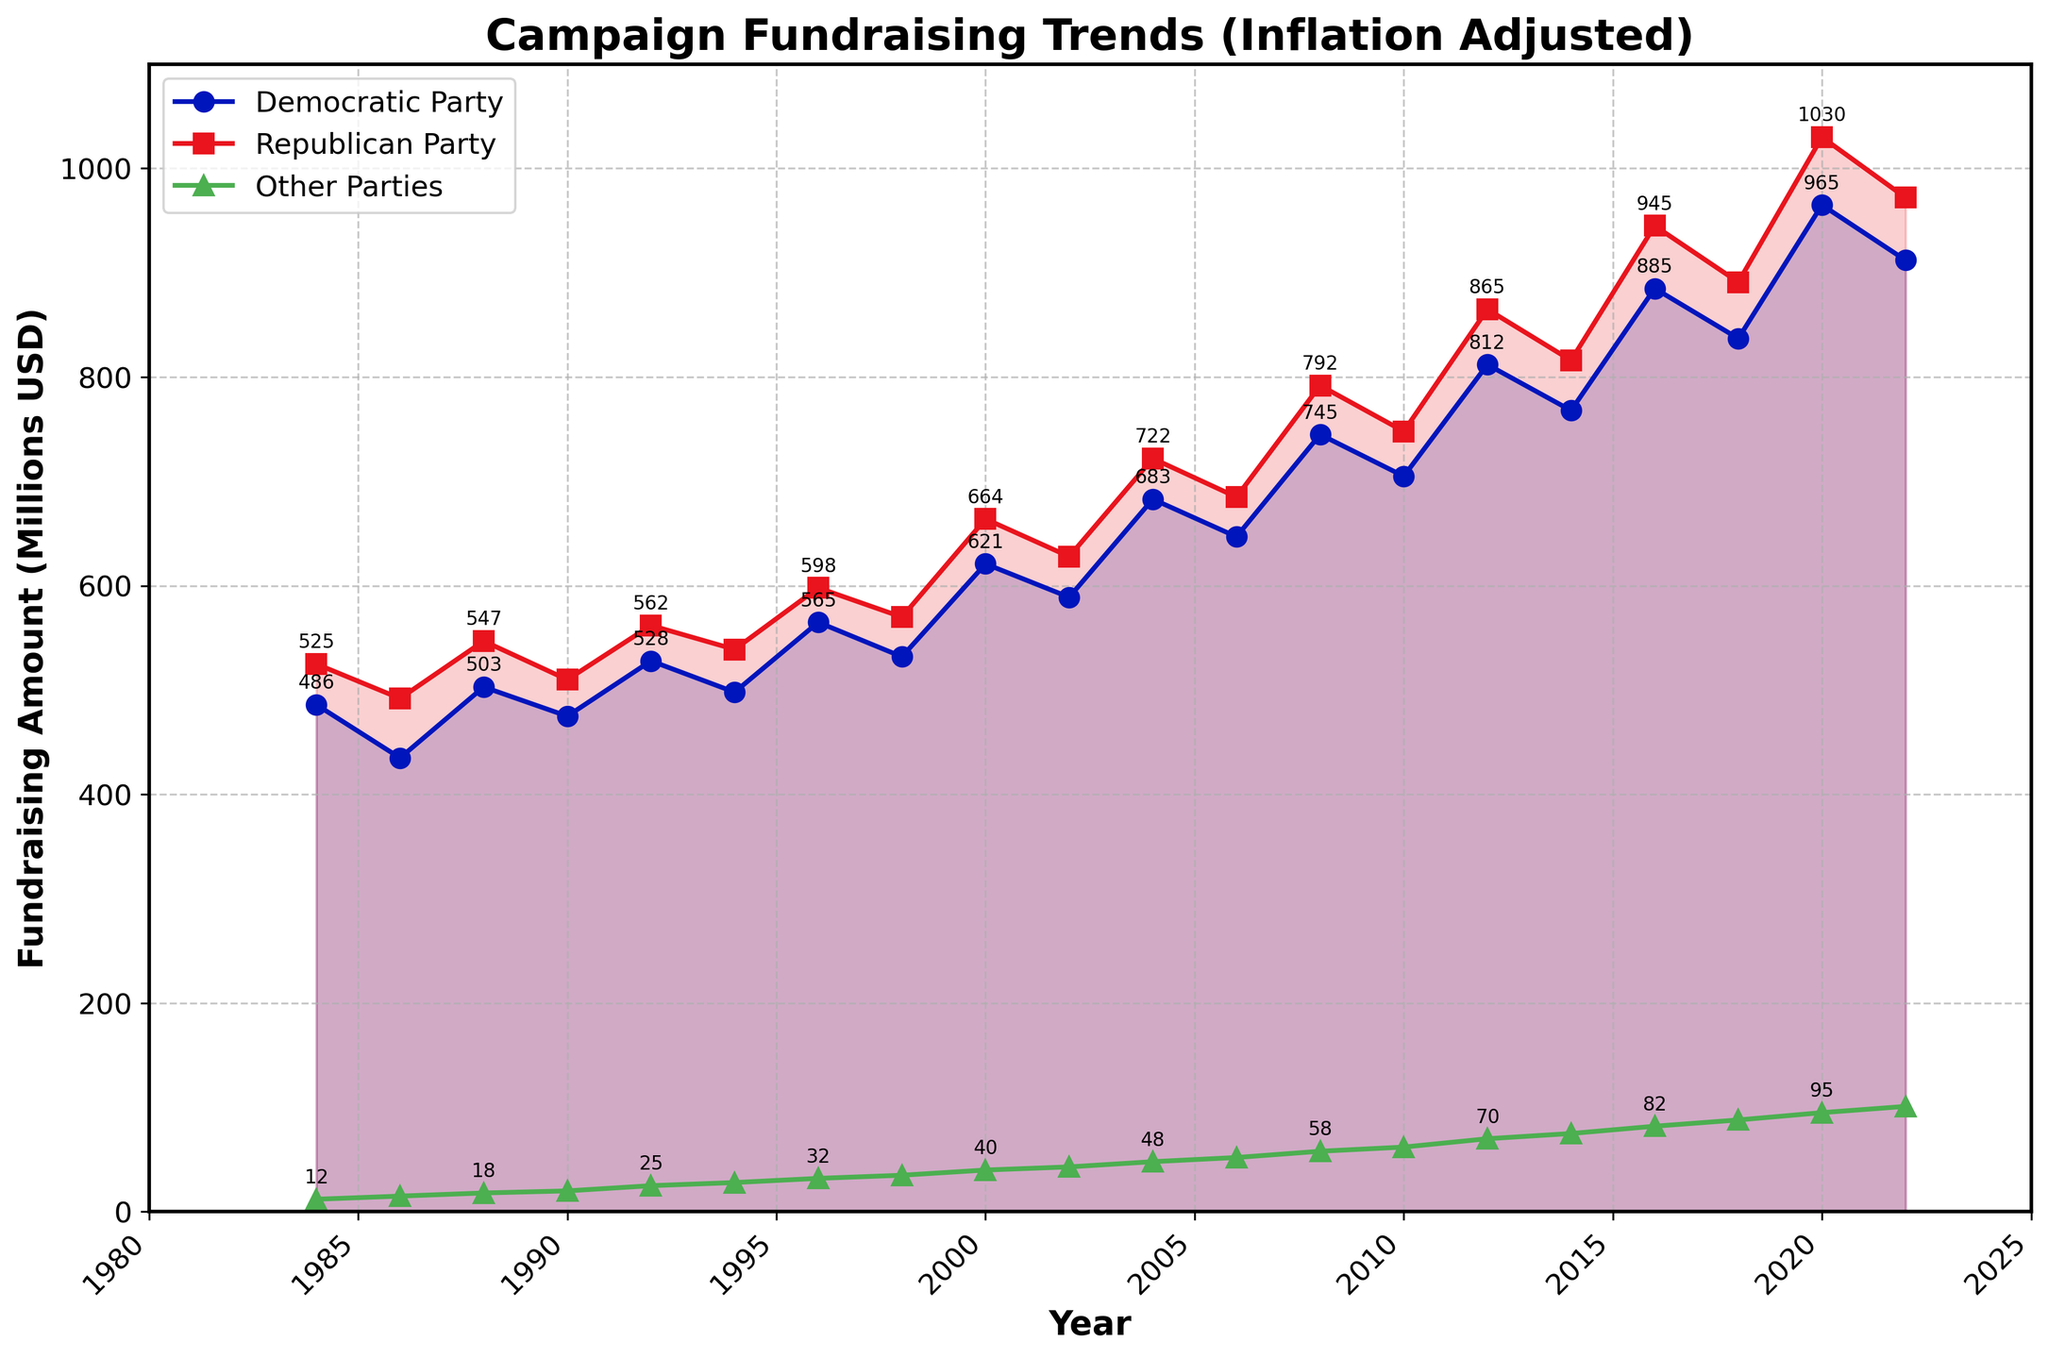What’s the total fundraising amount for Democratic and Republican parties in the year 2008? In 2008, the Democratic Party raised $745 million, and the Republican Party raised $792 million. Adding these amounts gives $745 + $792 = $1,537 million.
Answer: $1,537 million Which party had the highest fundraising in 2016? Comparing the amounts raised in 2016: The Democratic Party raised $885 million, the Republican Party raised $945 million, and Other Parties raised $82 million. The Republican Party had the highest fundraising.
Answer: Republican Party Between which years did the Democratic Party see the largest increase in fundraising? To determine the largest increase, compare the changes year-over-year for the Democratic Party. The biggest jump was from 2014 ($768 million) to 2016 ($885 million), an increase of $117 million.
Answer: 2014-2016 What is the average fundraising amount for Other Parties over the last 10 election cycles? Sum the fundraising amounts for Other Parties for each election year and divide by 10: (12+15+18+20+25+28+32+35+40+43+48+52+58+62+70+75+82+88+95+101) million. The average fundraising is (1237/20) = 61.85 million.
Answer: 61.85 million What trend is noticeable for the Republican Party fundraising from 2000 to 2020? Observing the year-over-year values for the Republican Party from 2000 ($664 million) to 2020 ($1030 million) we see an overall increasing trend, with each cycle generally raising a higher amount than the previous one.
Answer: Increasing trend In which years did the Democratic Party raise more than the Republican Party? Checking the plot, the Democratic Party raised more in the years: 1986, 1990, 2002, and 2006.
Answer: 1986, 1990, 2002, 2006 How much more did the Republican Party raise compared to the Democratic Party in 2020? In 2020, the Republican Party raised $1030 million, while the Democratic Party raised $965 million. The difference is $1030 - $965 = $65 million.
Answer: $65 million What color represents the fundraising trend of Other Parties in the chart? The Other Parties are represented by a green line with triangular markers.
Answer: Green By how much did the total fundraising of all parties increase from 1984 to 2022? Calculate the total fundraising amounts for 1984 and 2022: (486+525+12) million and (912+972+101) million respectively. The increase is (1985 - 1023) = 962 million.
Answer: $962 million What was the fundraising amount for the Republican Party in 2000, and how does it compare to its 2020 fundraising amount? The Republican Party raised $664 million in 2000 and $1030 million in 2020. The 2020 amount is $1030 - $664 = $366 million more than the 2000 amount.
Answer: $366 million more 